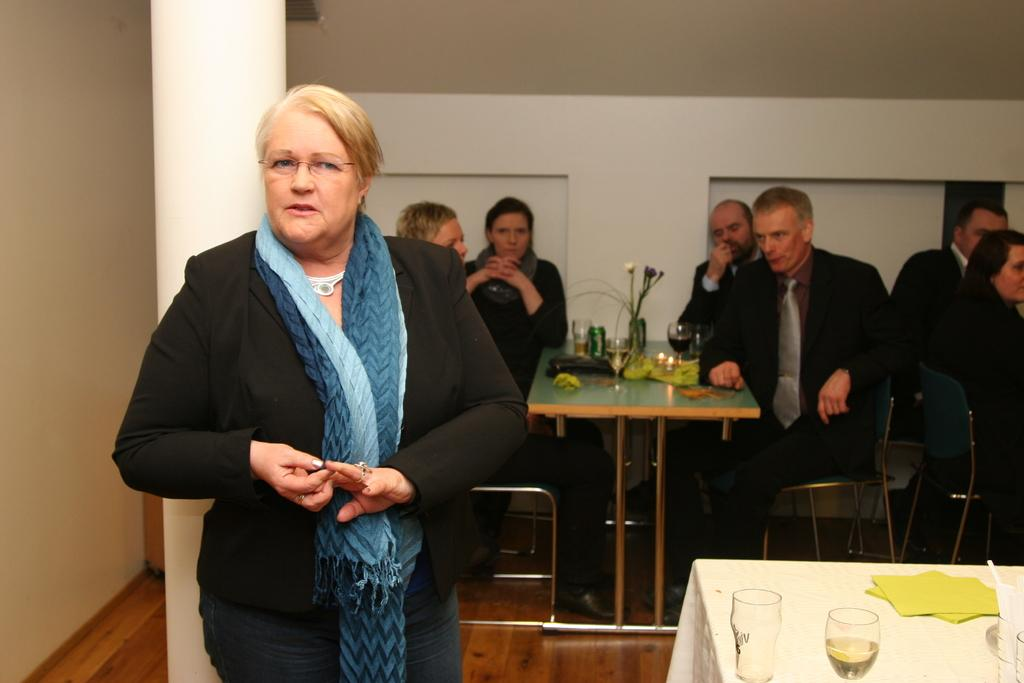What type of clothing is the woman wearing on her upper body in the image? The woman is wearing a black jacket. What accessory is the woman wearing around her neck in the image? The woman is wearing a scarf. What are the people in the image doing? The people are sitting on chairs. What is in front of the people while they are sitting? There is a table in front of the people. What items can be seen on the table in the image? There are glasses, a tin, and a bag on the table. How many bananas are on the table in the image? There are no bananas present on the table in the image. What type of roll is visible on the table in the image? There is no roll visible on the table in the image. 